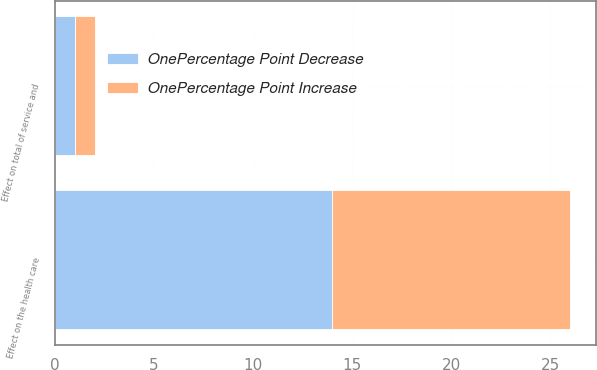Convert chart to OTSL. <chart><loc_0><loc_0><loc_500><loc_500><stacked_bar_chart><ecel><fcel>Effect on total of service and<fcel>Effect on the health care<nl><fcel>OnePercentage Point Decrease<fcel>1<fcel>14<nl><fcel>OnePercentage Point Increase<fcel>1<fcel>12<nl></chart> 